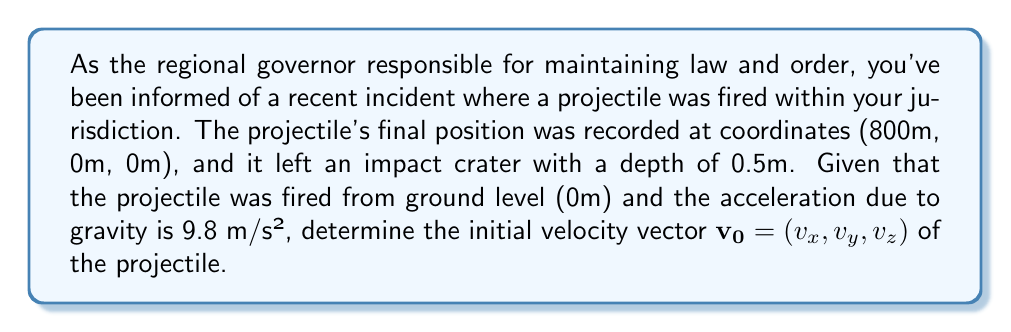Could you help me with this problem? Let's approach this step-by-step:

1) First, we can determine that this is a two-dimensional problem since the z-coordinate remains 0 throughout the trajectory.

2) The time of flight can be calculated using the vertical displacement equation:
   $$y = y_0 + v_yt - \frac{1}{2}gt^2$$
   
   At the point of impact, y = 0, y_0 = 0, so:
   $$0 = v_yt - \frac{1}{2}(9.8)t^2$$

3) We don't know $v_y$ yet, but we can express it in terms of t:
   $$v_y = \frac{1}{2}(9.8)t = 4.9t$$

4) For the horizontal motion, we use:
   $$x = v_xt$$
   $$800 = v_xt$$
   $$v_x = \frac{800}{t}$$

5) Now, we need to find t. We can use the concept of impact depth to estimate the vertical velocity at impact:
   $$v_f^2 = v_i^2 + 2ad$$
   where $v_f = 0$ (final velocity at the bottom of the crater), $a = 9.8 m/s^2$, and $d = 0.5m$

6) Solving for $v_i$ (impact velocity):
   $$v_i = \sqrt{2(9.8)(0.5)} = 3.13 m/s$$

7) The vertical velocity at impact is also given by:
   $$v_y(impact) = v_y - gt = 4.9t - 9.8t = -4.9t = -3.13$$

8) Solving for t:
   $$t = \frac{3.13}{4.9} = 0.639 s$$

9) Now we can find $v_x$ and $v_y$:
   $$v_x = \frac{800}{0.639} = 1251.95 m/s$$
   $$v_y = 4.9(0.639) = 3.13 m/s$$

Therefore, the initial velocity vector is $\mathbf{v_0} = (1251.95, 3.13, 0)$ m/s.
Answer: $\mathbf{v_0} = (1251.95, 3.13, 0)$ m/s 